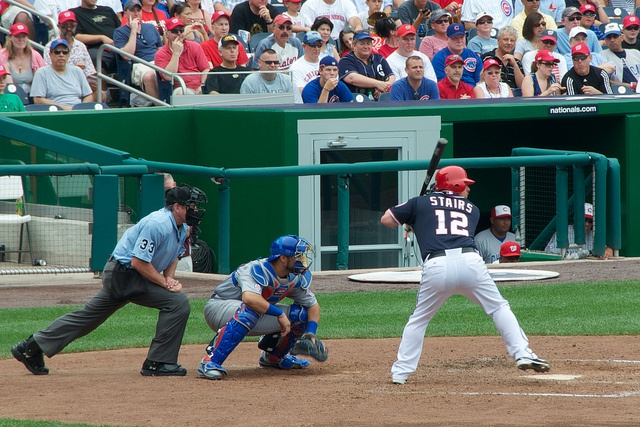Describe the objects in this image and their specific colors. I can see people in darkgray, black, gray, blue, and lightblue tones, people in darkgray, lightgray, navy, and black tones, people in darkgray, black, gray, and navy tones, people in darkgray, lightgray, lightblue, and gray tones, and people in darkgray, navy, black, brown, and gray tones in this image. 